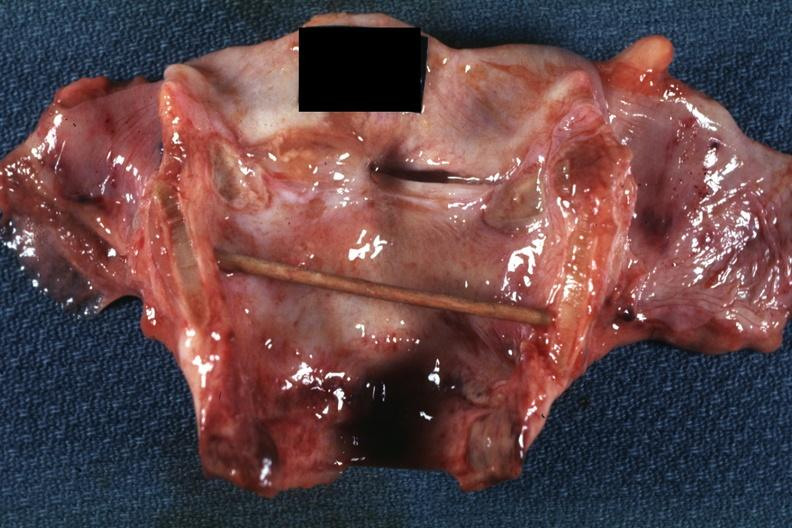s larynx present?
Answer the question using a single word or phrase. No 